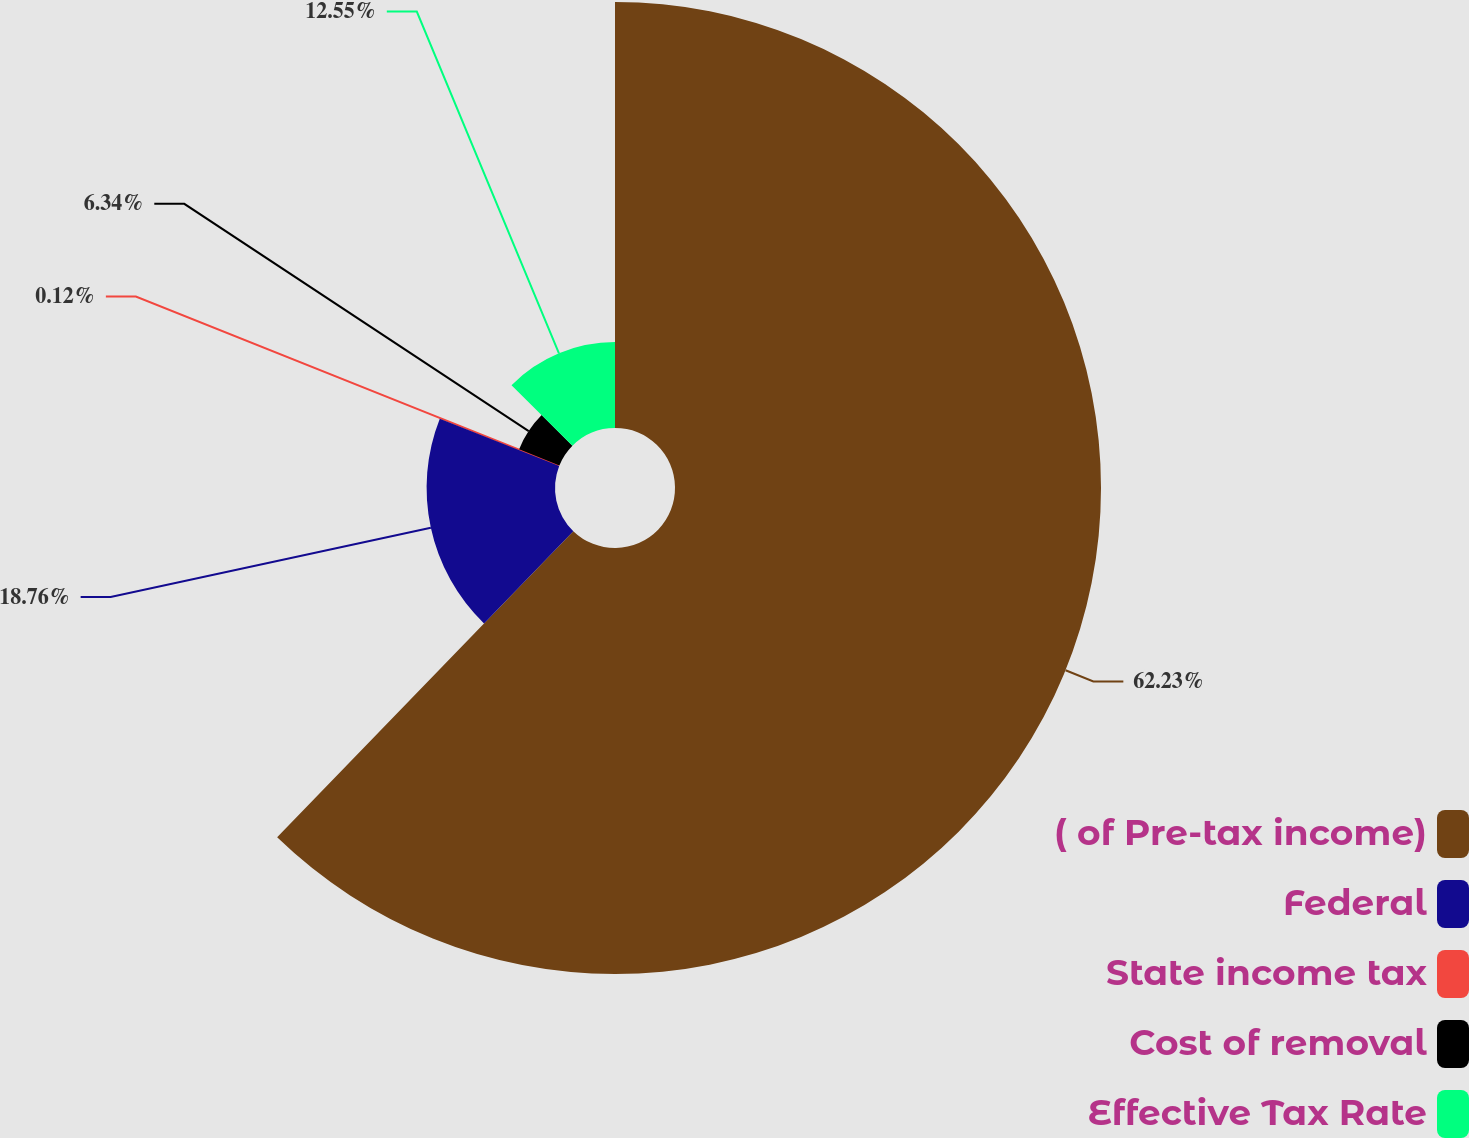Convert chart. <chart><loc_0><loc_0><loc_500><loc_500><pie_chart><fcel>( of Pre-tax income)<fcel>Federal<fcel>State income tax<fcel>Cost of removal<fcel>Effective Tax Rate<nl><fcel>62.24%<fcel>18.76%<fcel>0.12%<fcel>6.34%<fcel>12.55%<nl></chart> 